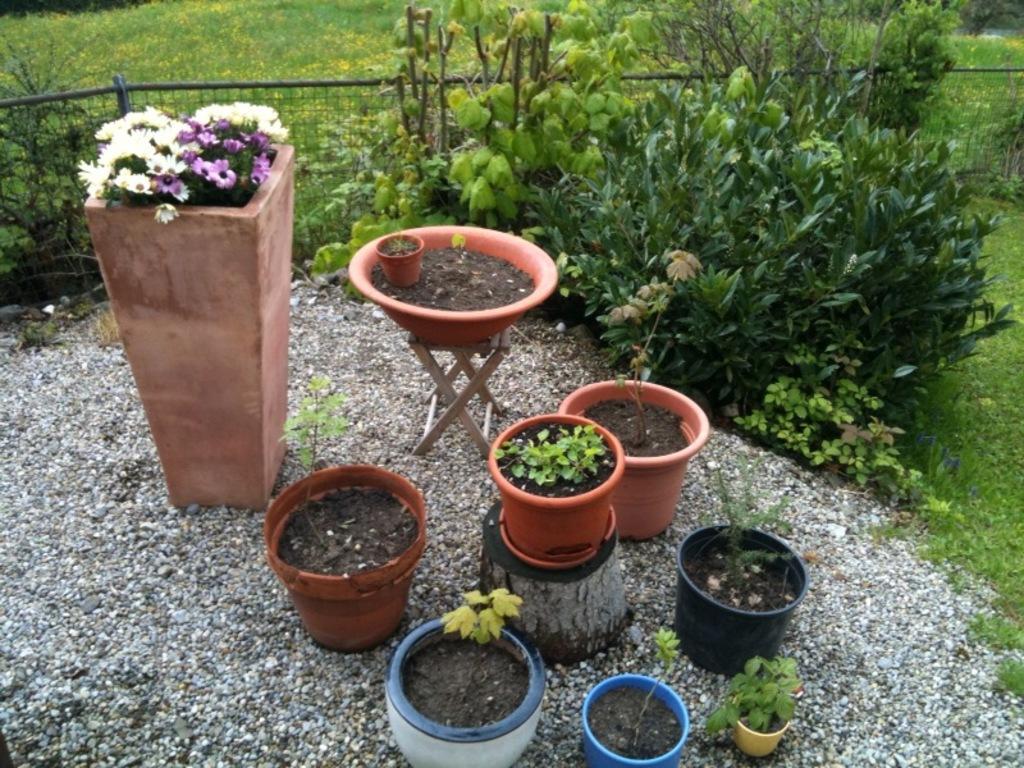Please provide a concise description of this image. Here we can see plants, pots, and flowers. This is grass and there is a fence. 